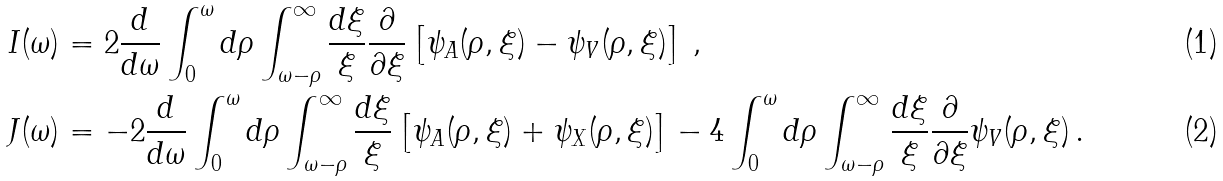<formula> <loc_0><loc_0><loc_500><loc_500>& I ( \omega ) = 2 \frac { d } { d \omega } \int _ { 0 } ^ { \omega } d \rho \int _ { \omega - \rho } ^ { \infty } \frac { d \xi } { \xi } \frac { \partial } { \partial \xi } \left [ \psi _ { A } ( \rho , \xi ) - \psi _ { V } ( \rho , \xi ) \right ] \, , \\ & J ( \omega ) = - 2 \frac { d } { d \omega } \int _ { 0 } ^ { \omega } d \rho \int _ { \omega - \rho } ^ { \infty } \frac { d \xi } { \xi } \left [ \psi _ { A } ( \rho , \xi ) + \psi _ { X } ( \rho , \xi ) \right ] - 4 \int _ { 0 } ^ { \omega } d \rho \int _ { \omega - \rho } ^ { \infty } \frac { d \xi } { \xi } \frac { \partial } { \partial \xi } \psi _ { V } ( \rho , \xi ) \, .</formula> 